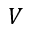<formula> <loc_0><loc_0><loc_500><loc_500>V</formula> 